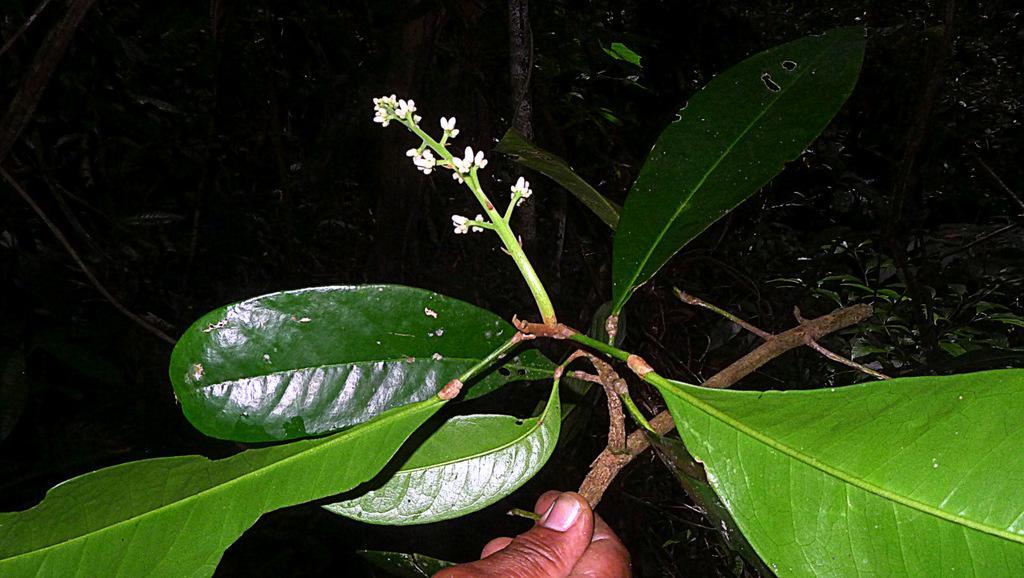Can you describe this image briefly? In this picture I can see a tree and a branch with flower and I can see a human hand holding the branch. 